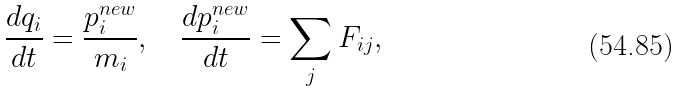Convert formula to latex. <formula><loc_0><loc_0><loc_500><loc_500>\frac { d q _ { i } } { d t } = \frac { p ^ { n e w } _ { i } } { m _ { i } } , \quad \frac { d p ^ { n e w } _ { i } } { d t } = \sum _ { j } F _ { i j } ,</formula> 